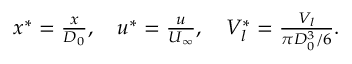Convert formula to latex. <formula><loc_0><loc_0><loc_500><loc_500>\begin{array} { r } { x ^ { * } = \frac { x } { D _ { 0 } } , \quad u ^ { * } = \frac { u } { U _ { \infty } } , \quad V _ { l } ^ { * } = \frac { V _ { l } } { \pi D _ { 0 } ^ { 3 } / 6 } . } \end{array}</formula> 